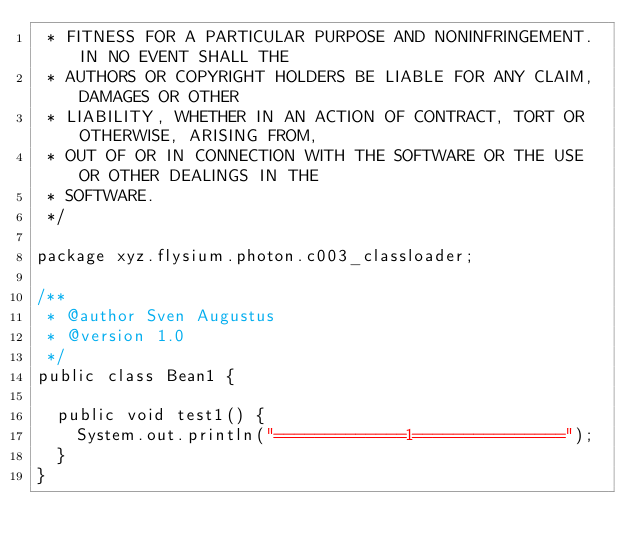<code> <loc_0><loc_0><loc_500><loc_500><_Java_> * FITNESS FOR A PARTICULAR PURPOSE AND NONINFRINGEMENT. IN NO EVENT SHALL THE
 * AUTHORS OR COPYRIGHT HOLDERS BE LIABLE FOR ANY CLAIM, DAMAGES OR OTHER
 * LIABILITY, WHETHER IN AN ACTION OF CONTRACT, TORT OR OTHERWISE, ARISING FROM,
 * OUT OF OR IN CONNECTION WITH THE SOFTWARE OR THE USE OR OTHER DEALINGS IN THE
 * SOFTWARE.
 */

package xyz.flysium.photon.c003_classloader;

/**
 * @author Sven Augustus
 * @version 1.0
 */
public class Bean1 {

  public void test1() {
    System.out.println("=============1===============");
  }
}</code> 